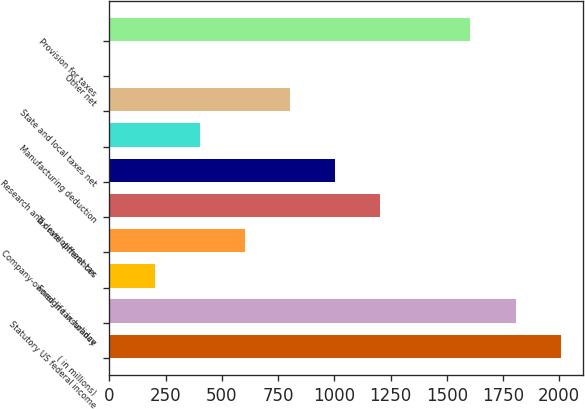Convert chart to OTSL. <chart><loc_0><loc_0><loc_500><loc_500><bar_chart><fcel>( in millions)<fcel>Statutory US federal income<fcel>Foreign tax holiday<fcel>Company-owned life insurance<fcel>Tax rate differences<fcel>Research and development tax<fcel>Manufacturing deduction<fcel>State and local taxes net<fcel>Other net<fcel>Provision for taxes<nl><fcel>2007<fcel>1806.34<fcel>201.06<fcel>602.38<fcel>1204.36<fcel>1003.7<fcel>401.72<fcel>803.04<fcel>0.4<fcel>1605.68<nl></chart> 